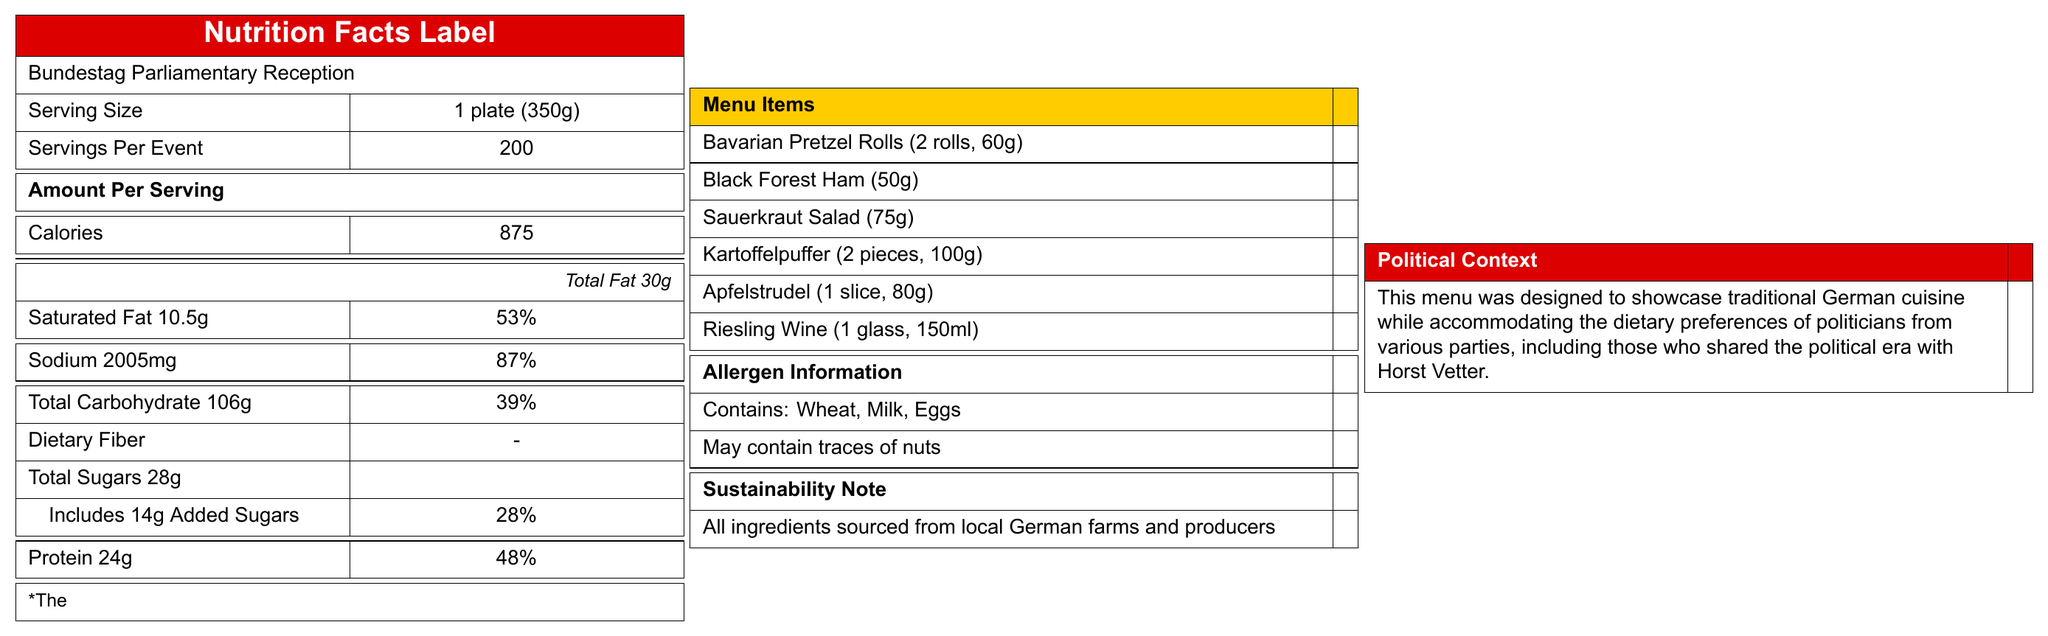what is the serving size for each portion? The document states that the Serving Size is 1 plate (350g).
Answer: 1 plate (350g) how much added sugar does the Sauerkraut Salad contain? The document outlines that the Sauerkraut Salad contains 1g of added sugars.
Answer: 1g how many calories does a portion of Apfelstrudel have? The document specifies that a portion size of Apfelstrudel is 1 slice (80g) and it contains 260 calories.
Answer: 260 calories what is the total carbohydrate content in the menu per serving? The Total Nutritional Breakdown section of the document indicates that each serving contains 106g of carbohydrates.
Answer: 106g how much protein is there in a portion of Black Forest Ham? The document lists that a 50g portion of Black Forest Ham contains 10g of protein.
Answer: 10g which menu item contains the highest amount of sodium? A. Bavarian Pretzel Rolls B. Black Forest Ham C. Sauerkraut Salad D. Apfelstrudel The document specifies that the Black Forest Ham contains 680mg of sodium, which is the highest among listed items.
Answer: B. Black Forest Ham which item has the most added sugars? 1. Riesling Wine 2. Apfelstrudel 3. Bavarian Pretzel Rolls 4. Kartoffelpuffer The document shows that Apfelstrudel contains 12g of added sugars, which is the highest among the items listed.
Answer: 2. Apfelstrudel is this menu designed with local ingredients? The document mentions in the Sustainability Note that all ingredients are sourced from local German farms and producers.
Answer: Yes is there information about dietary fibers in the menu? The document does not provide specific information about dietary fiber content.
Answer: No summarize the main focus of the document. The document aims to give a comprehensive overview of the nutritional value and origin of the menu items served at the Bundestag Parliamentary Reception, which includes traditional German cuisine chosen to accommodate the dietary preferences of politicians present.
Answer: The document provides nutritional information for a catering menu at a Bundestag Parliamentary Reception, including details on serving sizes, the nutritional breakdown of individual menu items, allergen information, and a sustainability note about sourcing local ingredients. what was Horst Vetter's stance on local farming practices? The document does not provide any information or context regarding Horst Vetter's stance on local farming practices.
Answer: Not enough information 